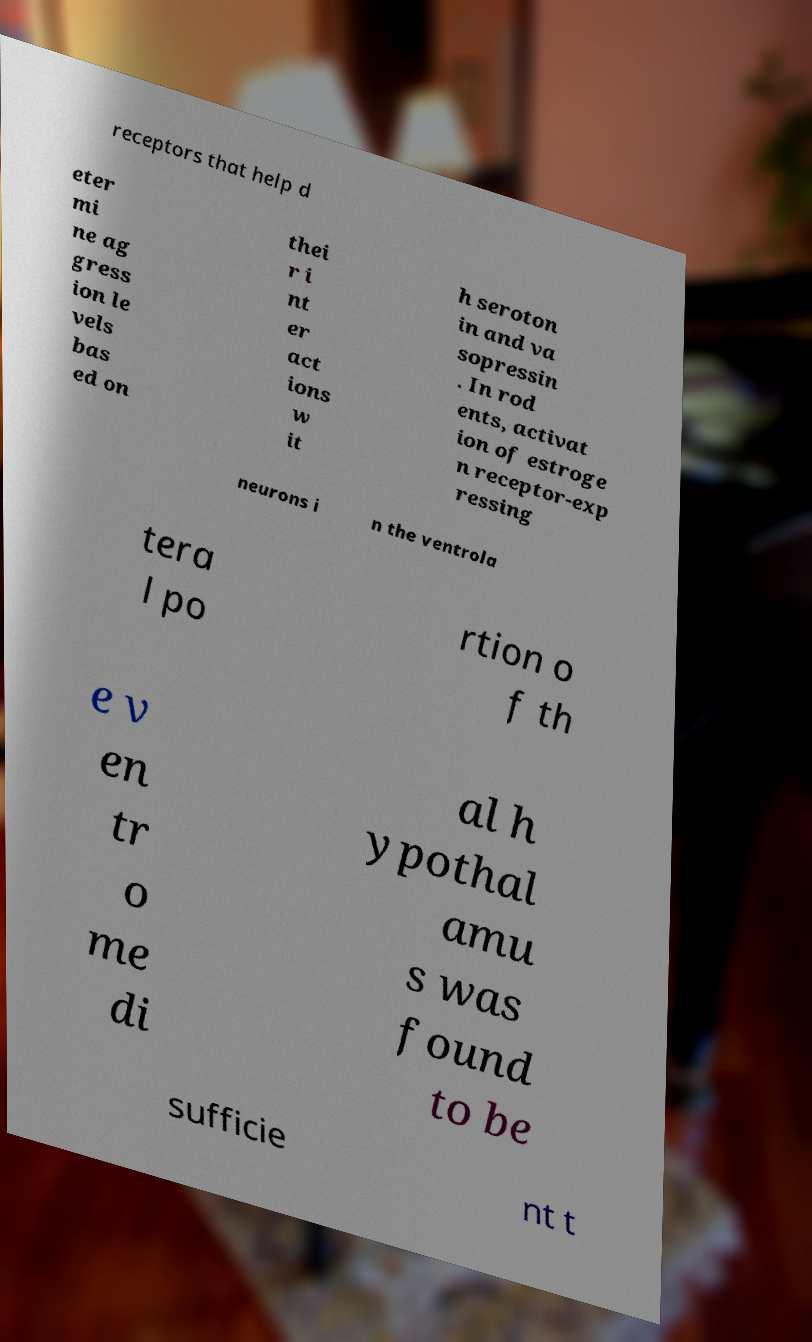Could you extract and type out the text from this image? receptors that help d eter mi ne ag gress ion le vels bas ed on thei r i nt er act ions w it h seroton in and va sopressin . In rod ents, activat ion of estroge n receptor-exp ressing neurons i n the ventrola tera l po rtion o f th e v en tr o me di al h ypothal amu s was found to be sufficie nt t 